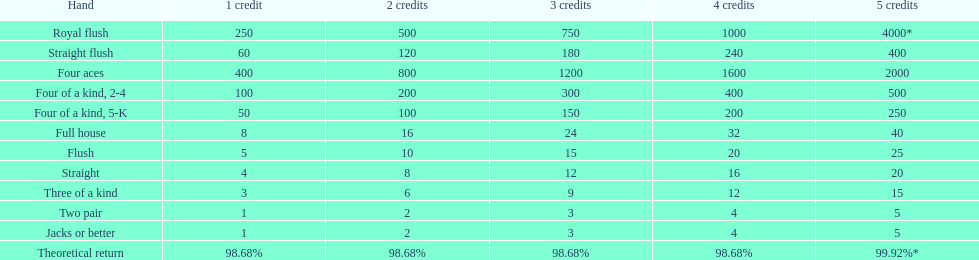What is the combined value of a 3-credit straight flush? 180. 